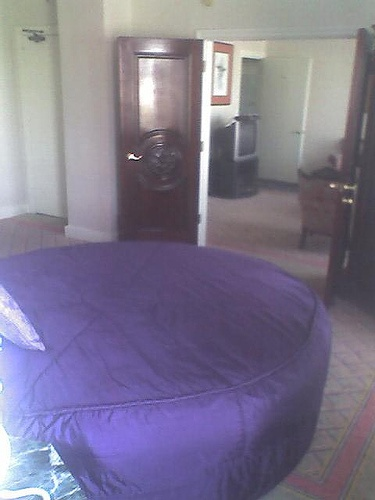Describe the objects in this image and their specific colors. I can see bed in darkgray, purple, and violet tones, couch in darkgray and gray tones, tv in darkgray, gray, and lightgray tones, and people in gray and darkgray tones in this image. 